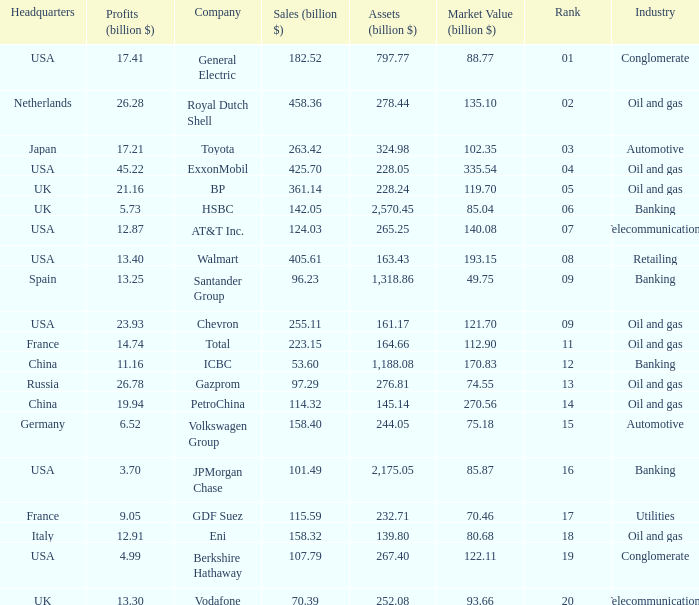Name the lowest Profits (billion $) which has a Sales (billion $) of 425.7, and a Rank larger than 4? None. 